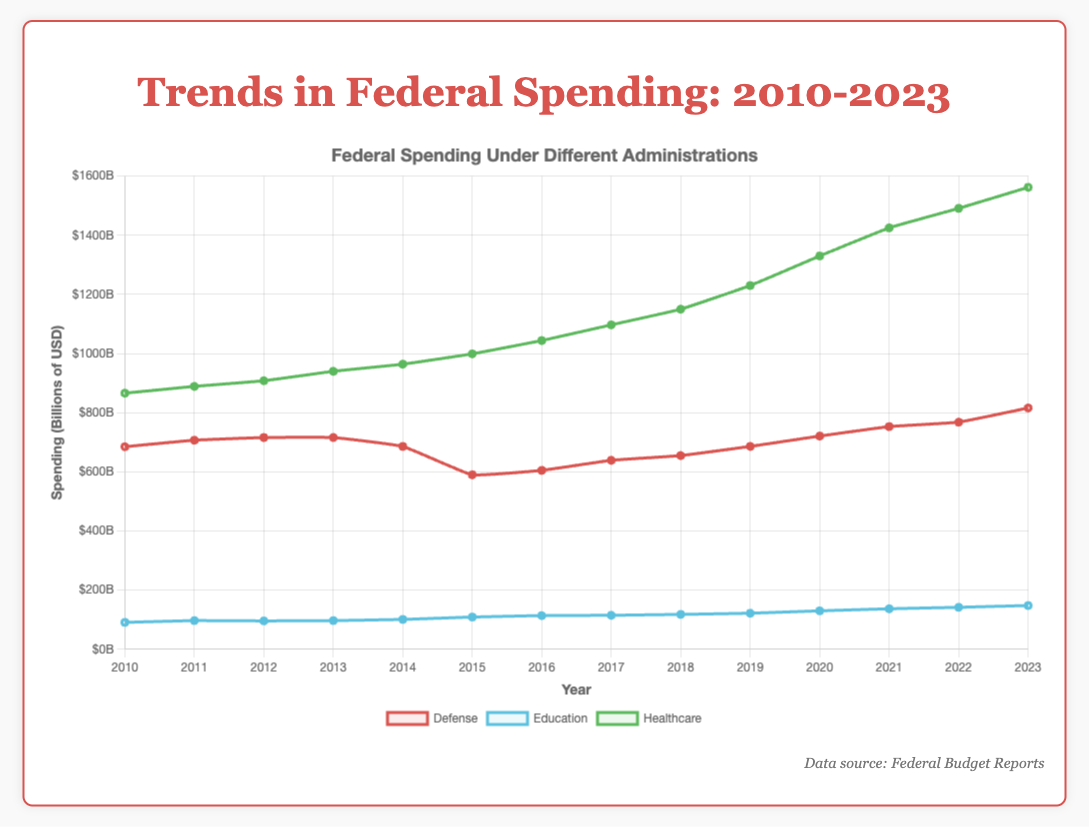Which sector had the highest federal spending in 2023? Look at the spending values for 2023 and identify the highest one. The Healthcare sector had the highest federal spending at $1562 billion.
Answer: Healthcare What is the difference in federal spending between Healthcare and Defense in 2023? Subtract the Defense spending in 2023 from the Healthcare spending in 2023: 1562 - 816 = 746.
Answer: 746 billion How did Defense spending change from 2016 to 2017? Compare the Defense spending values for 2016 ($605 billion) and 2017 ($639 billion). The spending increased by 34 billion.
Answer: Increased by 34 billion By how much did Education spending increase from 2010 to 2023? Subtract the Education spending in 2010 from that in 2023: 148 - 91 = 57.
Answer: 57 billion Which sector showed the most consistent increase in spending over the years? Look for the sector where the spending increases steadily each year. The Healthcare sector consistently increased in spending from 2010 to 2023.
Answer: Healthcare Between what years did Defense spending reach its lowest point? Identify the lowest value for Defense spending and the corresponding year which is $590 billion in 2015.
Answer: 2015 What is the average federal spending on Education from 2010 to 2023? Sum the yearly Education spending amounts and divide by the number of years: (91 + 97 + 96 + 97 + 101 + 109 + 114 + 115 + 118 + 122 + 130 + 137 + 142 + 148) / 14 = 114.714.
Answer: 114.714 billion How does the trend in Defense spending compare between the Trump and Biden administrations? Compare the growth patterns in Defense spending between the years 2016-2020 (Trump) and 2020-2023 (Biden). Under Trump, it shows gradual increases while under Biden, there is a noticeable spike in 2023.
Answer: Gradual increases (Trump), spike in 2023 (Biden) Which sector had the smallest increase in spending from 2010 to 2023? Calculate the increase in spending for each sector over the period and identify the smallest. Education had the smallest increase: 148 - 91 = 57.
Answer: Education When did Healthcare spending surpass $1000 billion? Look for the first year where Healthcare spending exceeds $1000 billion. It occurred in 2016 ($1044 billion).
Answer: 2016 